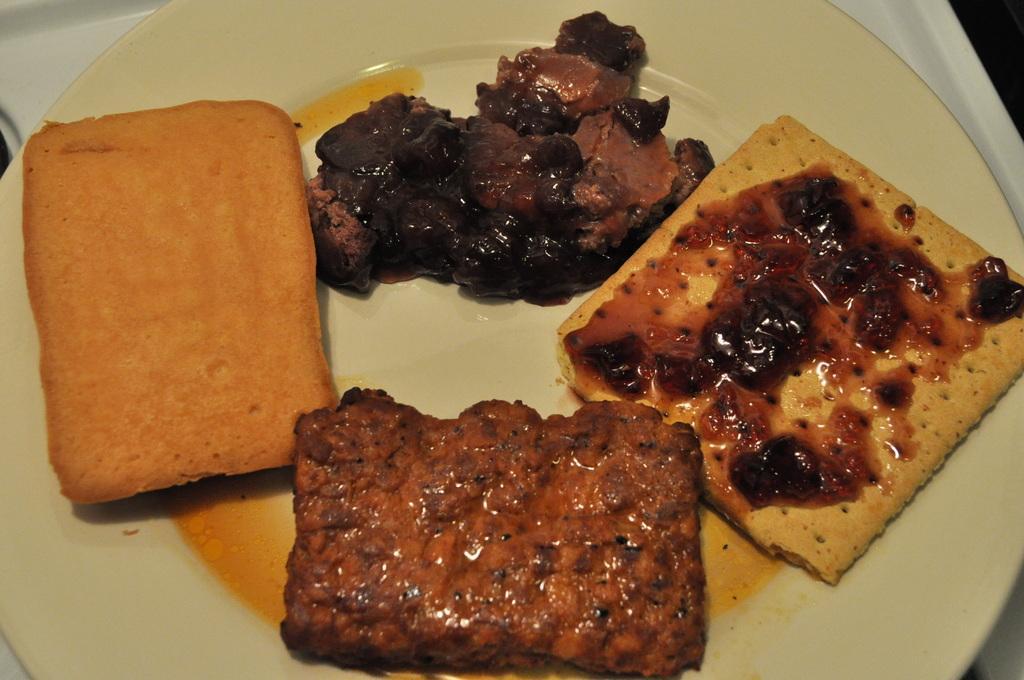In one or two sentences, can you explain what this image depicts? In this image there is a plate on a tray. There is some food on the plate. 